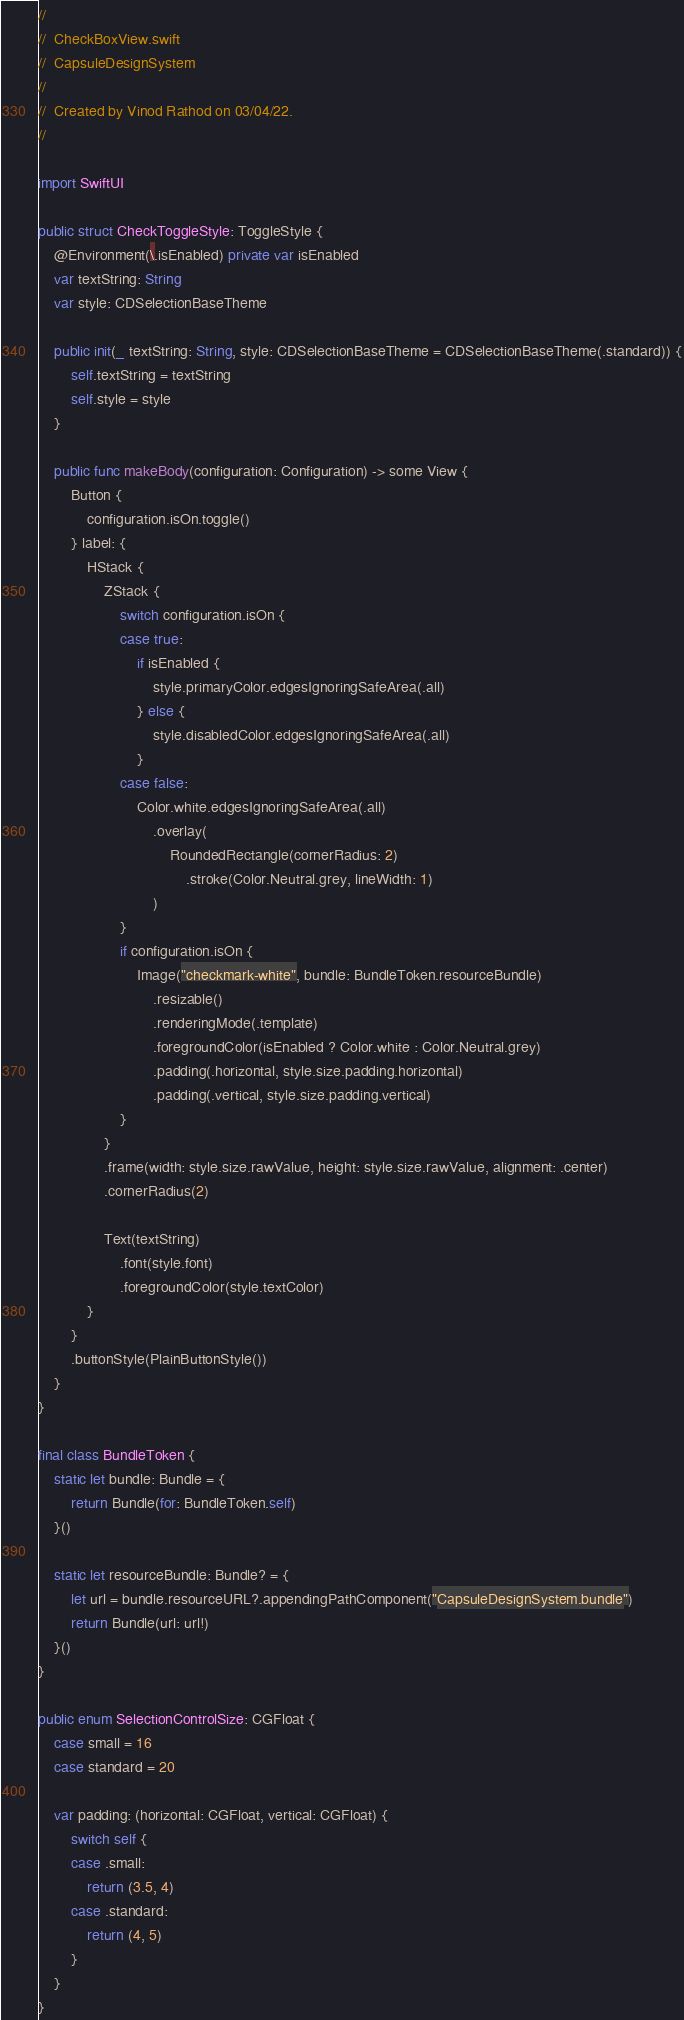<code> <loc_0><loc_0><loc_500><loc_500><_Swift_>//
//  CheckBoxView.swift
//  CapsuleDesignSystem
//
//  Created by Vinod Rathod on 03/04/22.
//

import SwiftUI

public struct CheckToggleStyle: ToggleStyle {
    @Environment(\.isEnabled) private var isEnabled
    var textString: String
    var style: CDSelectionBaseTheme
    
    public init(_ textString: String, style: CDSelectionBaseTheme = CDSelectionBaseTheme(.standard)) {
        self.textString = textString
        self.style = style
    }
    
    public func makeBody(configuration: Configuration) -> some View {
        Button {
            configuration.isOn.toggle()
        } label: {
            HStack {
                ZStack {
                    switch configuration.isOn {
                    case true:
                        if isEnabled {
                            style.primaryColor.edgesIgnoringSafeArea(.all)
                        } else {
                            style.disabledColor.edgesIgnoringSafeArea(.all)
                        }
                    case false:
                        Color.white.edgesIgnoringSafeArea(.all)
                            .overlay(
                                RoundedRectangle(cornerRadius: 2)
                                    .stroke(Color.Neutral.grey, lineWidth: 1)
                            )
                    }
                    if configuration.isOn {
                        Image("checkmark-white", bundle: BundleToken.resourceBundle)
                            .resizable()
                            .renderingMode(.template)
                            .foregroundColor(isEnabled ? Color.white : Color.Neutral.grey)
                            .padding(.horizontal, style.size.padding.horizontal)
                            .padding(.vertical, style.size.padding.vertical)
                    }
                }
                .frame(width: style.size.rawValue, height: style.size.rawValue, alignment: .center)
                .cornerRadius(2)
                
                Text(textString)
                    .font(style.font)
                    .foregroundColor(style.textColor)
            }
        }
        .buttonStyle(PlainButtonStyle())
    }
}

final class BundleToken {
    static let bundle: Bundle = {
        return Bundle(for: BundleToken.self)
    }()
    
    static let resourceBundle: Bundle? = {
        let url = bundle.resourceURL?.appendingPathComponent("CapsuleDesignSystem.bundle")
        return Bundle(url: url!)
    }()
}

public enum SelectionControlSize: CGFloat {
    case small = 16
    case standard = 20
    
    var padding: (horizontal: CGFloat, vertical: CGFloat) {
        switch self {
        case .small:
            return (3.5, 4)
        case .standard:
            return (4, 5)
        }
    }
}
</code> 